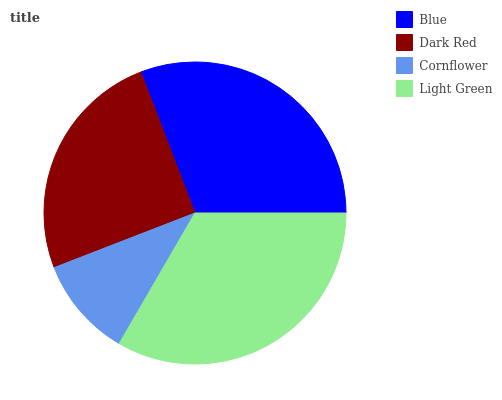Is Cornflower the minimum?
Answer yes or no. Yes. Is Light Green the maximum?
Answer yes or no. Yes. Is Dark Red the minimum?
Answer yes or no. No. Is Dark Red the maximum?
Answer yes or no. No. Is Blue greater than Dark Red?
Answer yes or no. Yes. Is Dark Red less than Blue?
Answer yes or no. Yes. Is Dark Red greater than Blue?
Answer yes or no. No. Is Blue less than Dark Red?
Answer yes or no. No. Is Blue the high median?
Answer yes or no. Yes. Is Dark Red the low median?
Answer yes or no. Yes. Is Cornflower the high median?
Answer yes or no. No. Is Blue the low median?
Answer yes or no. No. 